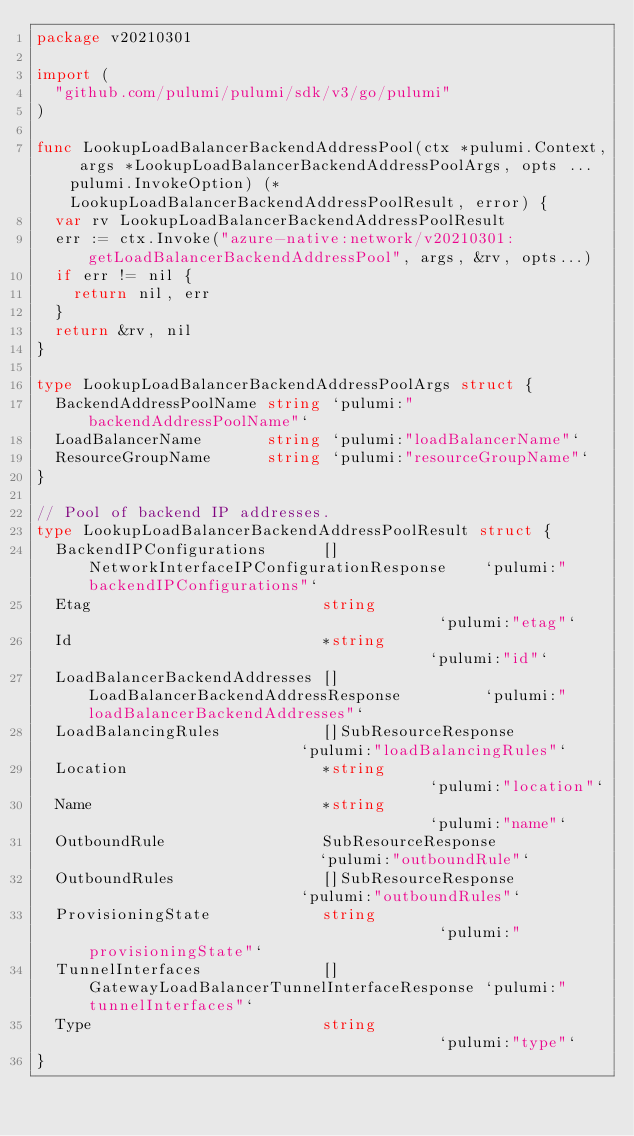Convert code to text. <code><loc_0><loc_0><loc_500><loc_500><_Go_>package v20210301

import (
	"github.com/pulumi/pulumi/sdk/v3/go/pulumi"
)

func LookupLoadBalancerBackendAddressPool(ctx *pulumi.Context, args *LookupLoadBalancerBackendAddressPoolArgs, opts ...pulumi.InvokeOption) (*LookupLoadBalancerBackendAddressPoolResult, error) {
	var rv LookupLoadBalancerBackendAddressPoolResult
	err := ctx.Invoke("azure-native:network/v20210301:getLoadBalancerBackendAddressPool", args, &rv, opts...)
	if err != nil {
		return nil, err
	}
	return &rv, nil
}

type LookupLoadBalancerBackendAddressPoolArgs struct {
	BackendAddressPoolName string `pulumi:"backendAddressPoolName"`
	LoadBalancerName       string `pulumi:"loadBalancerName"`
	ResourceGroupName      string `pulumi:"resourceGroupName"`
}

// Pool of backend IP addresses.
type LookupLoadBalancerBackendAddressPoolResult struct {
	BackendIPConfigurations      []NetworkInterfaceIPConfigurationResponse    `pulumi:"backendIPConfigurations"`
	Etag                         string                                       `pulumi:"etag"`
	Id                           *string                                      `pulumi:"id"`
	LoadBalancerBackendAddresses []LoadBalancerBackendAddressResponse         `pulumi:"loadBalancerBackendAddresses"`
	LoadBalancingRules           []SubResourceResponse                        `pulumi:"loadBalancingRules"`
	Location                     *string                                      `pulumi:"location"`
	Name                         *string                                      `pulumi:"name"`
	OutboundRule                 SubResourceResponse                          `pulumi:"outboundRule"`
	OutboundRules                []SubResourceResponse                        `pulumi:"outboundRules"`
	ProvisioningState            string                                       `pulumi:"provisioningState"`
	TunnelInterfaces             []GatewayLoadBalancerTunnelInterfaceResponse `pulumi:"tunnelInterfaces"`
	Type                         string                                       `pulumi:"type"`
}
</code> 